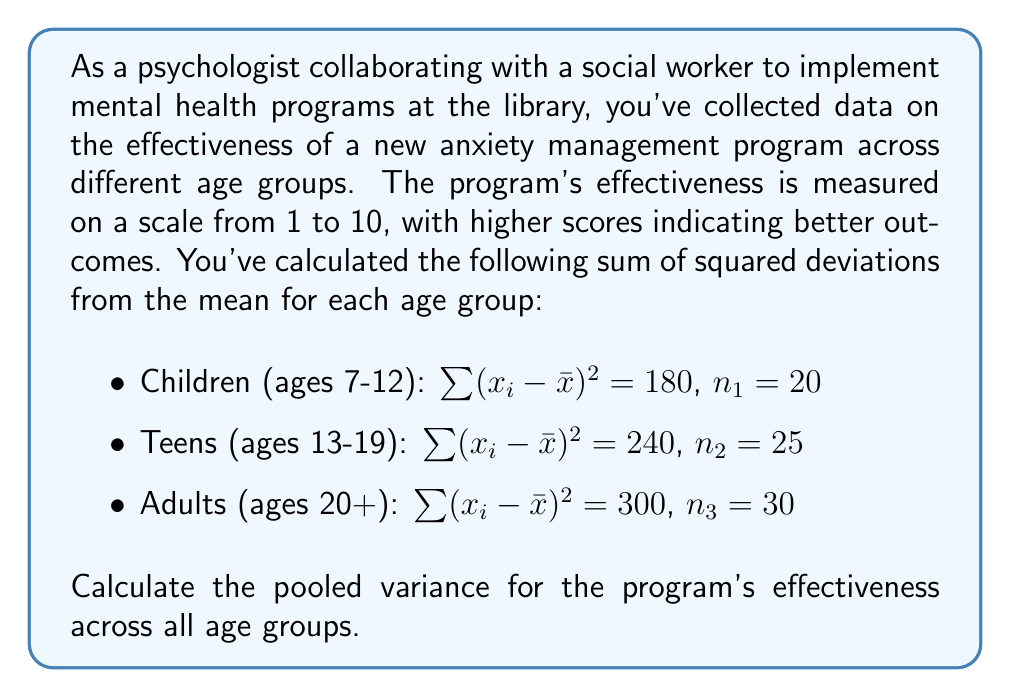Can you solve this math problem? To calculate the pooled variance, we need to follow these steps:

1) Recall the formula for pooled variance:

   $$s_p^2 = \frac{\sum_{i=1}^k (n_i - 1)s_i^2}{\sum_{i=1}^k (n_i - 1)}$$

   Where $s_p^2$ is the pooled variance, $k$ is the number of groups, $n_i$ is the sample size of each group, and $s_i^2$ is the variance of each group.

2) Calculate the variance for each group using the formula:

   $$s^2 = \frac{\sum(x_i - \bar{x})^2}{n - 1}$$

   For Children: $s_1^2 = \frac{180}{20 - 1} = 9.47$
   For Teens: $s_2^2 = \frac{240}{25 - 1} = 10$
   For Adults: $s_3^2 = \frac{300}{30 - 1} = 10.34$

3) Now, let's apply the pooled variance formula:

   $$s_p^2 = \frac{(20-1)(9.47) + (25-1)(10) + (30-1)(10.34)}{(20-1) + (25-1) + (30-1)}$$

4) Simplify:

   $$s_p^2 = \frac{179.93 + 240 + 300.86}{19 + 24 + 29}$$

5) Calculate:

   $$s_p^2 = \frac{720.79}{72} = 10.01$$

Thus, the pooled variance is approximately 10.01.
Answer: $s_p^2 = 10.01$ 